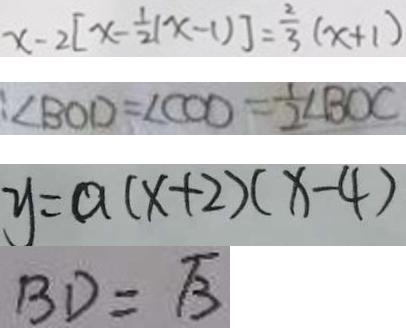Convert formula to latex. <formula><loc_0><loc_0><loc_500><loc_500>x - 2 [ x - \frac { 1 } { 2 } ( x - 1 ) ] = \frac { 2 } { 3 } ( x + 1 ) 
 : \angle B O D = \angle C O D = \frac { 1 } { 2 } \angle B O C 
 y = a ( x + 2 ) ( x - 4 ) 
 B D = \sqrt { 3 }</formula> 